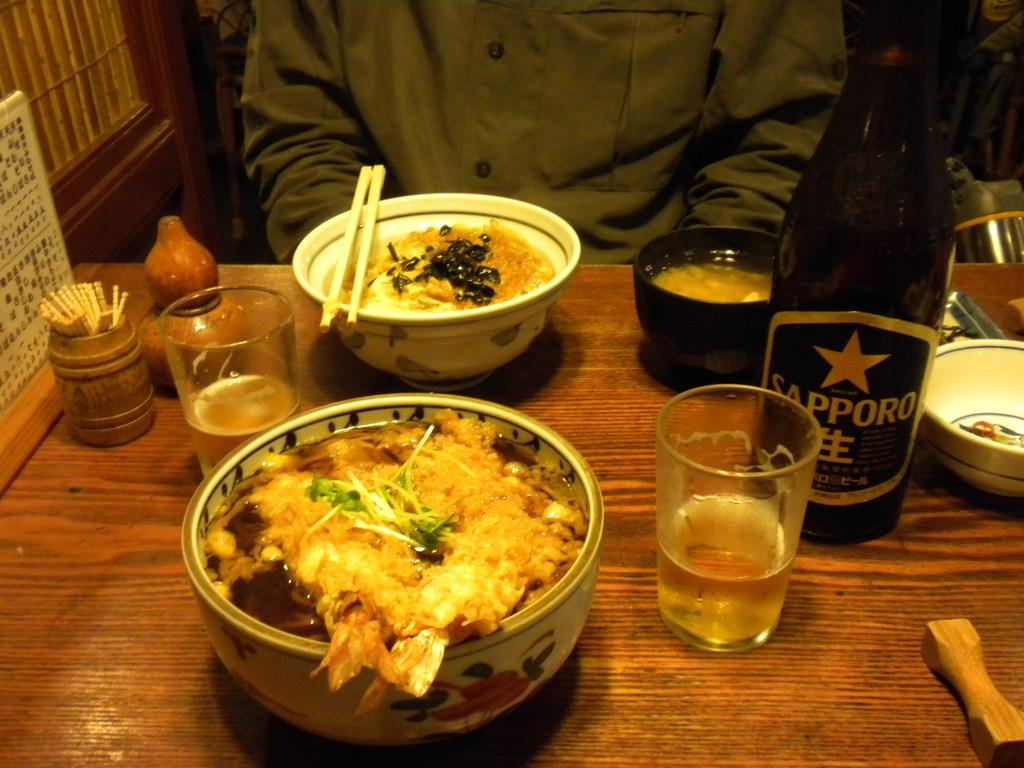Describe this image in one or two sentences. In this image we can see food items and few objects on a table. Behind the table, we can see a person. In the top left, we can see a wooden object. 